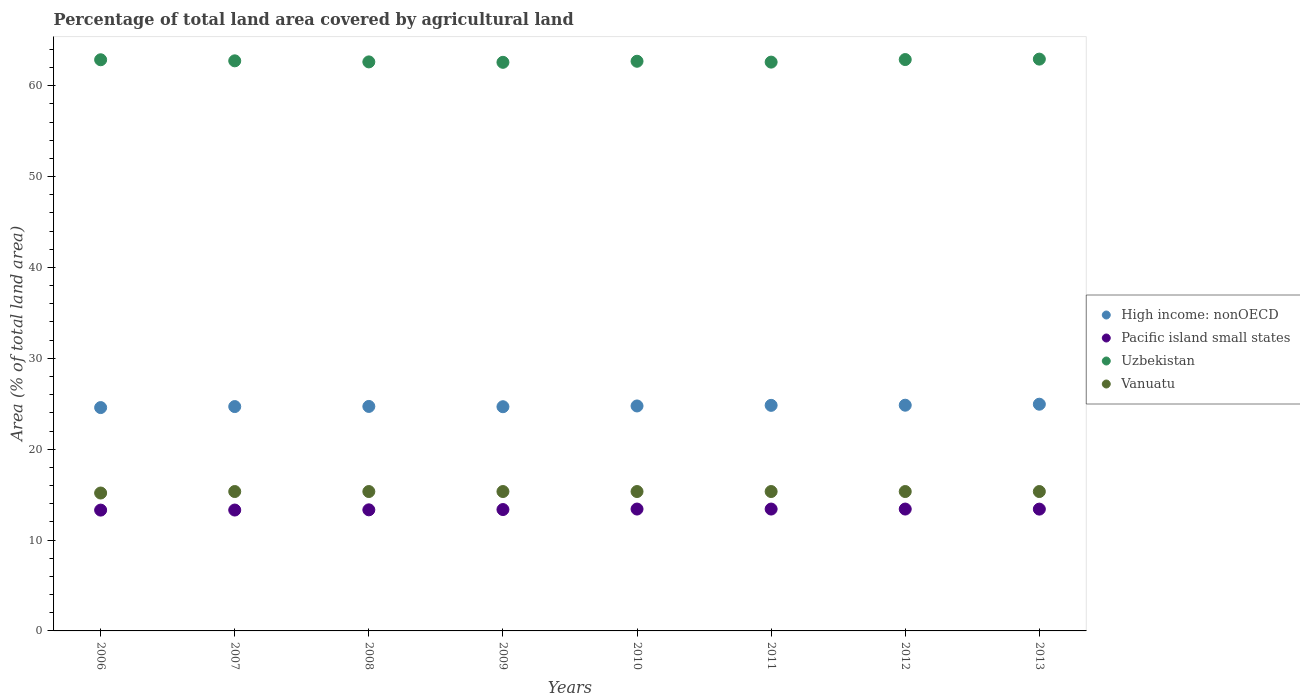How many different coloured dotlines are there?
Offer a terse response. 4. Is the number of dotlines equal to the number of legend labels?
Make the answer very short. Yes. What is the percentage of agricultural land in Vanuatu in 2013?
Offer a very short reply. 15.34. Across all years, what is the maximum percentage of agricultural land in Vanuatu?
Ensure brevity in your answer.  15.34. Across all years, what is the minimum percentage of agricultural land in Pacific island small states?
Your answer should be compact. 13.3. In which year was the percentage of agricultural land in Vanuatu maximum?
Provide a succinct answer. 2007. In which year was the percentage of agricultural land in High income: nonOECD minimum?
Offer a terse response. 2006. What is the total percentage of agricultural land in Pacific island small states in the graph?
Provide a succinct answer. 106.93. What is the difference between the percentage of agricultural land in Uzbekistan in 2006 and that in 2007?
Keep it short and to the point. 0.12. What is the difference between the percentage of agricultural land in Uzbekistan in 2010 and the percentage of agricultural land in High income: nonOECD in 2007?
Offer a terse response. 38. What is the average percentage of agricultural land in High income: nonOECD per year?
Your response must be concise. 24.75. In the year 2013, what is the difference between the percentage of agricultural land in Uzbekistan and percentage of agricultural land in High income: nonOECD?
Offer a terse response. 37.98. In how many years, is the percentage of agricultural land in Pacific island small states greater than 34 %?
Make the answer very short. 0. What is the ratio of the percentage of agricultural land in Pacific island small states in 2009 to that in 2010?
Provide a short and direct response. 1. What is the difference between the highest and the second highest percentage of agricultural land in Vanuatu?
Your response must be concise. 0. What is the difference between the highest and the lowest percentage of agricultural land in Vanuatu?
Your answer should be very brief. 0.16. Is the sum of the percentage of agricultural land in High income: nonOECD in 2007 and 2013 greater than the maximum percentage of agricultural land in Uzbekistan across all years?
Provide a short and direct response. No. Is it the case that in every year, the sum of the percentage of agricultural land in Uzbekistan and percentage of agricultural land in High income: nonOECD  is greater than the sum of percentage of agricultural land in Vanuatu and percentage of agricultural land in Pacific island small states?
Provide a succinct answer. Yes. Does the percentage of agricultural land in Vanuatu monotonically increase over the years?
Offer a terse response. No. Does the graph contain any zero values?
Your response must be concise. No. Does the graph contain grids?
Your answer should be very brief. No. How are the legend labels stacked?
Make the answer very short. Vertical. What is the title of the graph?
Make the answer very short. Percentage of total land area covered by agricultural land. Does "Malawi" appear as one of the legend labels in the graph?
Your response must be concise. No. What is the label or title of the X-axis?
Make the answer very short. Years. What is the label or title of the Y-axis?
Keep it short and to the point. Area (% of total land area). What is the Area (% of total land area) in High income: nonOECD in 2006?
Ensure brevity in your answer.  24.58. What is the Area (% of total land area) in Pacific island small states in 2006?
Offer a terse response. 13.3. What is the Area (% of total land area) in Uzbekistan in 2006?
Your response must be concise. 62.86. What is the Area (% of total land area) in Vanuatu in 2006?
Offer a terse response. 15.18. What is the Area (% of total land area) in High income: nonOECD in 2007?
Offer a terse response. 24.69. What is the Area (% of total land area) of Pacific island small states in 2007?
Offer a terse response. 13.3. What is the Area (% of total land area) of Uzbekistan in 2007?
Keep it short and to the point. 62.74. What is the Area (% of total land area) of Vanuatu in 2007?
Provide a short and direct response. 15.34. What is the Area (% of total land area) in High income: nonOECD in 2008?
Your response must be concise. 24.71. What is the Area (% of total land area) in Pacific island small states in 2008?
Provide a succinct answer. 13.33. What is the Area (% of total land area) in Uzbekistan in 2008?
Ensure brevity in your answer.  62.62. What is the Area (% of total land area) of Vanuatu in 2008?
Offer a terse response. 15.34. What is the Area (% of total land area) in High income: nonOECD in 2009?
Give a very brief answer. 24.67. What is the Area (% of total land area) of Pacific island small states in 2009?
Give a very brief answer. 13.36. What is the Area (% of total land area) of Uzbekistan in 2009?
Your response must be concise. 62.58. What is the Area (% of total land area) in Vanuatu in 2009?
Make the answer very short. 15.34. What is the Area (% of total land area) of High income: nonOECD in 2010?
Your response must be concise. 24.76. What is the Area (% of total land area) of Pacific island small states in 2010?
Make the answer very short. 13.41. What is the Area (% of total land area) of Uzbekistan in 2010?
Offer a terse response. 62.69. What is the Area (% of total land area) of Vanuatu in 2010?
Make the answer very short. 15.34. What is the Area (% of total land area) in High income: nonOECD in 2011?
Your answer should be compact. 24.83. What is the Area (% of total land area) of Pacific island small states in 2011?
Provide a succinct answer. 13.41. What is the Area (% of total land area) of Uzbekistan in 2011?
Provide a succinct answer. 62.6. What is the Area (% of total land area) of Vanuatu in 2011?
Offer a terse response. 15.34. What is the Area (% of total land area) in High income: nonOECD in 2012?
Make the answer very short. 24.84. What is the Area (% of total land area) in Pacific island small states in 2012?
Make the answer very short. 13.41. What is the Area (% of total land area) in Uzbekistan in 2012?
Keep it short and to the point. 62.88. What is the Area (% of total land area) in Vanuatu in 2012?
Your response must be concise. 15.34. What is the Area (% of total land area) of High income: nonOECD in 2013?
Provide a succinct answer. 24.95. What is the Area (% of total land area) of Pacific island small states in 2013?
Your answer should be compact. 13.4. What is the Area (% of total land area) of Uzbekistan in 2013?
Your answer should be very brief. 62.93. What is the Area (% of total land area) of Vanuatu in 2013?
Give a very brief answer. 15.34. Across all years, what is the maximum Area (% of total land area) in High income: nonOECD?
Provide a succinct answer. 24.95. Across all years, what is the maximum Area (% of total land area) in Pacific island small states?
Provide a short and direct response. 13.41. Across all years, what is the maximum Area (% of total land area) in Uzbekistan?
Make the answer very short. 62.93. Across all years, what is the maximum Area (% of total land area) in Vanuatu?
Your response must be concise. 15.34. Across all years, what is the minimum Area (% of total land area) in High income: nonOECD?
Provide a succinct answer. 24.58. Across all years, what is the minimum Area (% of total land area) of Pacific island small states?
Give a very brief answer. 13.3. Across all years, what is the minimum Area (% of total land area) in Uzbekistan?
Offer a terse response. 62.58. Across all years, what is the minimum Area (% of total land area) in Vanuatu?
Your answer should be compact. 15.18. What is the total Area (% of total land area) of High income: nonOECD in the graph?
Your answer should be very brief. 198.03. What is the total Area (% of total land area) of Pacific island small states in the graph?
Provide a short and direct response. 106.93. What is the total Area (% of total land area) of Uzbekistan in the graph?
Provide a succinct answer. 501.9. What is the total Area (% of total land area) of Vanuatu in the graph?
Ensure brevity in your answer.  122.56. What is the difference between the Area (% of total land area) in High income: nonOECD in 2006 and that in 2007?
Offer a very short reply. -0.11. What is the difference between the Area (% of total land area) of Pacific island small states in 2006 and that in 2007?
Give a very brief answer. -0.01. What is the difference between the Area (% of total land area) of Uzbekistan in 2006 and that in 2007?
Offer a terse response. 0.12. What is the difference between the Area (% of total land area) of Vanuatu in 2006 and that in 2007?
Your answer should be very brief. -0.16. What is the difference between the Area (% of total land area) of High income: nonOECD in 2006 and that in 2008?
Offer a very short reply. -0.13. What is the difference between the Area (% of total land area) in Pacific island small states in 2006 and that in 2008?
Your response must be concise. -0.03. What is the difference between the Area (% of total land area) in Uzbekistan in 2006 and that in 2008?
Your response must be concise. 0.24. What is the difference between the Area (% of total land area) in Vanuatu in 2006 and that in 2008?
Your answer should be very brief. -0.16. What is the difference between the Area (% of total land area) in High income: nonOECD in 2006 and that in 2009?
Your answer should be very brief. -0.09. What is the difference between the Area (% of total land area) of Pacific island small states in 2006 and that in 2009?
Give a very brief answer. -0.06. What is the difference between the Area (% of total land area) of Uzbekistan in 2006 and that in 2009?
Provide a succinct answer. 0.28. What is the difference between the Area (% of total land area) of Vanuatu in 2006 and that in 2009?
Make the answer very short. -0.16. What is the difference between the Area (% of total land area) in High income: nonOECD in 2006 and that in 2010?
Provide a short and direct response. -0.18. What is the difference between the Area (% of total land area) of Pacific island small states in 2006 and that in 2010?
Provide a short and direct response. -0.12. What is the difference between the Area (% of total land area) in Uzbekistan in 2006 and that in 2010?
Offer a very short reply. 0.16. What is the difference between the Area (% of total land area) in Vanuatu in 2006 and that in 2010?
Offer a terse response. -0.16. What is the difference between the Area (% of total land area) in High income: nonOECD in 2006 and that in 2011?
Your answer should be very brief. -0.25. What is the difference between the Area (% of total land area) of Pacific island small states in 2006 and that in 2011?
Offer a terse response. -0.12. What is the difference between the Area (% of total land area) of Uzbekistan in 2006 and that in 2011?
Your response must be concise. 0.26. What is the difference between the Area (% of total land area) in Vanuatu in 2006 and that in 2011?
Give a very brief answer. -0.16. What is the difference between the Area (% of total land area) of High income: nonOECD in 2006 and that in 2012?
Your answer should be very brief. -0.26. What is the difference between the Area (% of total land area) in Pacific island small states in 2006 and that in 2012?
Provide a succinct answer. -0.12. What is the difference between the Area (% of total land area) of Uzbekistan in 2006 and that in 2012?
Ensure brevity in your answer.  -0.02. What is the difference between the Area (% of total land area) of Vanuatu in 2006 and that in 2012?
Provide a short and direct response. -0.16. What is the difference between the Area (% of total land area) of High income: nonOECD in 2006 and that in 2013?
Ensure brevity in your answer.  -0.37. What is the difference between the Area (% of total land area) in Pacific island small states in 2006 and that in 2013?
Keep it short and to the point. -0.11. What is the difference between the Area (% of total land area) in Uzbekistan in 2006 and that in 2013?
Your response must be concise. -0.07. What is the difference between the Area (% of total land area) of Vanuatu in 2006 and that in 2013?
Offer a terse response. -0.16. What is the difference between the Area (% of total land area) in High income: nonOECD in 2007 and that in 2008?
Ensure brevity in your answer.  -0.02. What is the difference between the Area (% of total land area) of Pacific island small states in 2007 and that in 2008?
Provide a succinct answer. -0.02. What is the difference between the Area (% of total land area) in Uzbekistan in 2007 and that in 2008?
Keep it short and to the point. 0.12. What is the difference between the Area (% of total land area) in High income: nonOECD in 2007 and that in 2009?
Ensure brevity in your answer.  0.02. What is the difference between the Area (% of total land area) of Pacific island small states in 2007 and that in 2009?
Offer a very short reply. -0.05. What is the difference between the Area (% of total land area) of Uzbekistan in 2007 and that in 2009?
Ensure brevity in your answer.  0.16. What is the difference between the Area (% of total land area) in Vanuatu in 2007 and that in 2009?
Give a very brief answer. 0. What is the difference between the Area (% of total land area) of High income: nonOECD in 2007 and that in 2010?
Offer a very short reply. -0.07. What is the difference between the Area (% of total land area) of Pacific island small states in 2007 and that in 2010?
Offer a terse response. -0.11. What is the difference between the Area (% of total land area) in Uzbekistan in 2007 and that in 2010?
Offer a terse response. 0.05. What is the difference between the Area (% of total land area) of Vanuatu in 2007 and that in 2010?
Your response must be concise. 0. What is the difference between the Area (% of total land area) of High income: nonOECD in 2007 and that in 2011?
Give a very brief answer. -0.13. What is the difference between the Area (% of total land area) in Pacific island small states in 2007 and that in 2011?
Offer a very short reply. -0.11. What is the difference between the Area (% of total land area) of Uzbekistan in 2007 and that in 2011?
Keep it short and to the point. 0.14. What is the difference between the Area (% of total land area) in High income: nonOECD in 2007 and that in 2012?
Provide a short and direct response. -0.15. What is the difference between the Area (% of total land area) of Pacific island small states in 2007 and that in 2012?
Give a very brief answer. -0.11. What is the difference between the Area (% of total land area) in Uzbekistan in 2007 and that in 2012?
Offer a very short reply. -0.14. What is the difference between the Area (% of total land area) in Vanuatu in 2007 and that in 2012?
Give a very brief answer. 0. What is the difference between the Area (% of total land area) of High income: nonOECD in 2007 and that in 2013?
Make the answer very short. -0.26. What is the difference between the Area (% of total land area) in Pacific island small states in 2007 and that in 2013?
Provide a succinct answer. -0.1. What is the difference between the Area (% of total land area) in Uzbekistan in 2007 and that in 2013?
Offer a very short reply. -0.19. What is the difference between the Area (% of total land area) of High income: nonOECD in 2008 and that in 2009?
Your answer should be very brief. 0.03. What is the difference between the Area (% of total land area) of Pacific island small states in 2008 and that in 2009?
Keep it short and to the point. -0.03. What is the difference between the Area (% of total land area) of Uzbekistan in 2008 and that in 2009?
Offer a very short reply. 0.05. What is the difference between the Area (% of total land area) in High income: nonOECD in 2008 and that in 2010?
Your answer should be compact. -0.05. What is the difference between the Area (% of total land area) of Pacific island small states in 2008 and that in 2010?
Make the answer very short. -0.09. What is the difference between the Area (% of total land area) of Uzbekistan in 2008 and that in 2010?
Make the answer very short. -0.07. What is the difference between the Area (% of total land area) in Vanuatu in 2008 and that in 2010?
Give a very brief answer. 0. What is the difference between the Area (% of total land area) of High income: nonOECD in 2008 and that in 2011?
Provide a short and direct response. -0.12. What is the difference between the Area (% of total land area) in Pacific island small states in 2008 and that in 2011?
Make the answer very short. -0.09. What is the difference between the Area (% of total land area) of Uzbekistan in 2008 and that in 2011?
Ensure brevity in your answer.  0.02. What is the difference between the Area (% of total land area) of High income: nonOECD in 2008 and that in 2012?
Make the answer very short. -0.14. What is the difference between the Area (% of total land area) of Pacific island small states in 2008 and that in 2012?
Your response must be concise. -0.09. What is the difference between the Area (% of total land area) in Uzbekistan in 2008 and that in 2012?
Make the answer very short. -0.26. What is the difference between the Area (% of total land area) of Vanuatu in 2008 and that in 2012?
Offer a terse response. 0. What is the difference between the Area (% of total land area) in High income: nonOECD in 2008 and that in 2013?
Offer a terse response. -0.24. What is the difference between the Area (% of total land area) of Pacific island small states in 2008 and that in 2013?
Your answer should be compact. -0.08. What is the difference between the Area (% of total land area) in Uzbekistan in 2008 and that in 2013?
Offer a terse response. -0.31. What is the difference between the Area (% of total land area) of Vanuatu in 2008 and that in 2013?
Your answer should be very brief. 0. What is the difference between the Area (% of total land area) in High income: nonOECD in 2009 and that in 2010?
Your response must be concise. -0.08. What is the difference between the Area (% of total land area) of Pacific island small states in 2009 and that in 2010?
Your response must be concise. -0.05. What is the difference between the Area (% of total land area) of Uzbekistan in 2009 and that in 2010?
Keep it short and to the point. -0.12. What is the difference between the Area (% of total land area) in Vanuatu in 2009 and that in 2010?
Provide a short and direct response. 0. What is the difference between the Area (% of total land area) in High income: nonOECD in 2009 and that in 2011?
Ensure brevity in your answer.  -0.15. What is the difference between the Area (% of total land area) in Pacific island small states in 2009 and that in 2011?
Provide a succinct answer. -0.05. What is the difference between the Area (% of total land area) in Uzbekistan in 2009 and that in 2011?
Your response must be concise. -0.02. What is the difference between the Area (% of total land area) in Pacific island small states in 2009 and that in 2012?
Ensure brevity in your answer.  -0.05. What is the difference between the Area (% of total land area) of Uzbekistan in 2009 and that in 2012?
Provide a succinct answer. -0.31. What is the difference between the Area (% of total land area) in High income: nonOECD in 2009 and that in 2013?
Keep it short and to the point. -0.28. What is the difference between the Area (% of total land area) of Pacific island small states in 2009 and that in 2013?
Your response must be concise. -0.05. What is the difference between the Area (% of total land area) of Uzbekistan in 2009 and that in 2013?
Your response must be concise. -0.35. What is the difference between the Area (% of total land area) of High income: nonOECD in 2010 and that in 2011?
Your answer should be compact. -0.07. What is the difference between the Area (% of total land area) in Pacific island small states in 2010 and that in 2011?
Your answer should be compact. 0. What is the difference between the Area (% of total land area) of Uzbekistan in 2010 and that in 2011?
Your answer should be compact. 0.09. What is the difference between the Area (% of total land area) of Vanuatu in 2010 and that in 2011?
Offer a very short reply. 0. What is the difference between the Area (% of total land area) in High income: nonOECD in 2010 and that in 2012?
Provide a succinct answer. -0.08. What is the difference between the Area (% of total land area) in Pacific island small states in 2010 and that in 2012?
Your response must be concise. 0. What is the difference between the Area (% of total land area) of Uzbekistan in 2010 and that in 2012?
Ensure brevity in your answer.  -0.19. What is the difference between the Area (% of total land area) of High income: nonOECD in 2010 and that in 2013?
Offer a terse response. -0.19. What is the difference between the Area (% of total land area) in Pacific island small states in 2010 and that in 2013?
Make the answer very short. 0.01. What is the difference between the Area (% of total land area) in Uzbekistan in 2010 and that in 2013?
Give a very brief answer. -0.24. What is the difference between the Area (% of total land area) of Vanuatu in 2010 and that in 2013?
Offer a terse response. 0. What is the difference between the Area (% of total land area) of High income: nonOECD in 2011 and that in 2012?
Give a very brief answer. -0.02. What is the difference between the Area (% of total land area) in Uzbekistan in 2011 and that in 2012?
Your answer should be very brief. -0.28. What is the difference between the Area (% of total land area) in High income: nonOECD in 2011 and that in 2013?
Provide a short and direct response. -0.12. What is the difference between the Area (% of total land area) of Pacific island small states in 2011 and that in 2013?
Provide a short and direct response. 0.01. What is the difference between the Area (% of total land area) of Uzbekistan in 2011 and that in 2013?
Ensure brevity in your answer.  -0.33. What is the difference between the Area (% of total land area) in Vanuatu in 2011 and that in 2013?
Provide a short and direct response. 0. What is the difference between the Area (% of total land area) in High income: nonOECD in 2012 and that in 2013?
Offer a very short reply. -0.11. What is the difference between the Area (% of total land area) of Pacific island small states in 2012 and that in 2013?
Your answer should be compact. 0.01. What is the difference between the Area (% of total land area) in Uzbekistan in 2012 and that in 2013?
Your response must be concise. -0.05. What is the difference between the Area (% of total land area) in High income: nonOECD in 2006 and the Area (% of total land area) in Pacific island small states in 2007?
Provide a short and direct response. 11.28. What is the difference between the Area (% of total land area) of High income: nonOECD in 2006 and the Area (% of total land area) of Uzbekistan in 2007?
Provide a short and direct response. -38.16. What is the difference between the Area (% of total land area) in High income: nonOECD in 2006 and the Area (% of total land area) in Vanuatu in 2007?
Provide a short and direct response. 9.24. What is the difference between the Area (% of total land area) of Pacific island small states in 2006 and the Area (% of total land area) of Uzbekistan in 2007?
Your answer should be very brief. -49.44. What is the difference between the Area (% of total land area) of Pacific island small states in 2006 and the Area (% of total land area) of Vanuatu in 2007?
Provide a short and direct response. -2.04. What is the difference between the Area (% of total land area) of Uzbekistan in 2006 and the Area (% of total land area) of Vanuatu in 2007?
Your answer should be compact. 47.52. What is the difference between the Area (% of total land area) in High income: nonOECD in 2006 and the Area (% of total land area) in Pacific island small states in 2008?
Provide a succinct answer. 11.25. What is the difference between the Area (% of total land area) of High income: nonOECD in 2006 and the Area (% of total land area) of Uzbekistan in 2008?
Your answer should be compact. -38.04. What is the difference between the Area (% of total land area) of High income: nonOECD in 2006 and the Area (% of total land area) of Vanuatu in 2008?
Offer a very short reply. 9.24. What is the difference between the Area (% of total land area) in Pacific island small states in 2006 and the Area (% of total land area) in Uzbekistan in 2008?
Offer a terse response. -49.33. What is the difference between the Area (% of total land area) in Pacific island small states in 2006 and the Area (% of total land area) in Vanuatu in 2008?
Your answer should be very brief. -2.04. What is the difference between the Area (% of total land area) in Uzbekistan in 2006 and the Area (% of total land area) in Vanuatu in 2008?
Provide a succinct answer. 47.52. What is the difference between the Area (% of total land area) in High income: nonOECD in 2006 and the Area (% of total land area) in Pacific island small states in 2009?
Your answer should be compact. 11.22. What is the difference between the Area (% of total land area) of High income: nonOECD in 2006 and the Area (% of total land area) of Uzbekistan in 2009?
Your answer should be compact. -38. What is the difference between the Area (% of total land area) of High income: nonOECD in 2006 and the Area (% of total land area) of Vanuatu in 2009?
Provide a short and direct response. 9.24. What is the difference between the Area (% of total land area) in Pacific island small states in 2006 and the Area (% of total land area) in Uzbekistan in 2009?
Provide a short and direct response. -49.28. What is the difference between the Area (% of total land area) of Pacific island small states in 2006 and the Area (% of total land area) of Vanuatu in 2009?
Provide a succinct answer. -2.04. What is the difference between the Area (% of total land area) in Uzbekistan in 2006 and the Area (% of total land area) in Vanuatu in 2009?
Offer a very short reply. 47.52. What is the difference between the Area (% of total land area) of High income: nonOECD in 2006 and the Area (% of total land area) of Pacific island small states in 2010?
Keep it short and to the point. 11.17. What is the difference between the Area (% of total land area) in High income: nonOECD in 2006 and the Area (% of total land area) in Uzbekistan in 2010?
Make the answer very short. -38.11. What is the difference between the Area (% of total land area) in High income: nonOECD in 2006 and the Area (% of total land area) in Vanuatu in 2010?
Provide a succinct answer. 9.24. What is the difference between the Area (% of total land area) of Pacific island small states in 2006 and the Area (% of total land area) of Uzbekistan in 2010?
Your response must be concise. -49.4. What is the difference between the Area (% of total land area) of Pacific island small states in 2006 and the Area (% of total land area) of Vanuatu in 2010?
Offer a terse response. -2.04. What is the difference between the Area (% of total land area) in Uzbekistan in 2006 and the Area (% of total land area) in Vanuatu in 2010?
Ensure brevity in your answer.  47.52. What is the difference between the Area (% of total land area) in High income: nonOECD in 2006 and the Area (% of total land area) in Pacific island small states in 2011?
Your answer should be very brief. 11.17. What is the difference between the Area (% of total land area) of High income: nonOECD in 2006 and the Area (% of total land area) of Uzbekistan in 2011?
Give a very brief answer. -38.02. What is the difference between the Area (% of total land area) of High income: nonOECD in 2006 and the Area (% of total land area) of Vanuatu in 2011?
Keep it short and to the point. 9.24. What is the difference between the Area (% of total land area) of Pacific island small states in 2006 and the Area (% of total land area) of Uzbekistan in 2011?
Provide a succinct answer. -49.3. What is the difference between the Area (% of total land area) in Pacific island small states in 2006 and the Area (% of total land area) in Vanuatu in 2011?
Your answer should be compact. -2.04. What is the difference between the Area (% of total land area) in Uzbekistan in 2006 and the Area (% of total land area) in Vanuatu in 2011?
Provide a short and direct response. 47.52. What is the difference between the Area (% of total land area) of High income: nonOECD in 2006 and the Area (% of total land area) of Pacific island small states in 2012?
Offer a very short reply. 11.17. What is the difference between the Area (% of total land area) of High income: nonOECD in 2006 and the Area (% of total land area) of Uzbekistan in 2012?
Ensure brevity in your answer.  -38.3. What is the difference between the Area (% of total land area) in High income: nonOECD in 2006 and the Area (% of total land area) in Vanuatu in 2012?
Ensure brevity in your answer.  9.24. What is the difference between the Area (% of total land area) in Pacific island small states in 2006 and the Area (% of total land area) in Uzbekistan in 2012?
Keep it short and to the point. -49.59. What is the difference between the Area (% of total land area) in Pacific island small states in 2006 and the Area (% of total land area) in Vanuatu in 2012?
Your answer should be compact. -2.04. What is the difference between the Area (% of total land area) in Uzbekistan in 2006 and the Area (% of total land area) in Vanuatu in 2012?
Ensure brevity in your answer.  47.52. What is the difference between the Area (% of total land area) of High income: nonOECD in 2006 and the Area (% of total land area) of Pacific island small states in 2013?
Ensure brevity in your answer.  11.18. What is the difference between the Area (% of total land area) in High income: nonOECD in 2006 and the Area (% of total land area) in Uzbekistan in 2013?
Your answer should be compact. -38.35. What is the difference between the Area (% of total land area) in High income: nonOECD in 2006 and the Area (% of total land area) in Vanuatu in 2013?
Your answer should be very brief. 9.24. What is the difference between the Area (% of total land area) in Pacific island small states in 2006 and the Area (% of total land area) in Uzbekistan in 2013?
Keep it short and to the point. -49.63. What is the difference between the Area (% of total land area) in Pacific island small states in 2006 and the Area (% of total land area) in Vanuatu in 2013?
Ensure brevity in your answer.  -2.04. What is the difference between the Area (% of total land area) in Uzbekistan in 2006 and the Area (% of total land area) in Vanuatu in 2013?
Your answer should be compact. 47.52. What is the difference between the Area (% of total land area) in High income: nonOECD in 2007 and the Area (% of total land area) in Pacific island small states in 2008?
Ensure brevity in your answer.  11.36. What is the difference between the Area (% of total land area) of High income: nonOECD in 2007 and the Area (% of total land area) of Uzbekistan in 2008?
Offer a terse response. -37.93. What is the difference between the Area (% of total land area) in High income: nonOECD in 2007 and the Area (% of total land area) in Vanuatu in 2008?
Your answer should be compact. 9.35. What is the difference between the Area (% of total land area) of Pacific island small states in 2007 and the Area (% of total land area) of Uzbekistan in 2008?
Make the answer very short. -49.32. What is the difference between the Area (% of total land area) in Pacific island small states in 2007 and the Area (% of total land area) in Vanuatu in 2008?
Offer a very short reply. -2.04. What is the difference between the Area (% of total land area) in Uzbekistan in 2007 and the Area (% of total land area) in Vanuatu in 2008?
Your answer should be compact. 47.4. What is the difference between the Area (% of total land area) of High income: nonOECD in 2007 and the Area (% of total land area) of Pacific island small states in 2009?
Provide a short and direct response. 11.33. What is the difference between the Area (% of total land area) of High income: nonOECD in 2007 and the Area (% of total land area) of Uzbekistan in 2009?
Your answer should be compact. -37.89. What is the difference between the Area (% of total land area) in High income: nonOECD in 2007 and the Area (% of total land area) in Vanuatu in 2009?
Your answer should be compact. 9.35. What is the difference between the Area (% of total land area) in Pacific island small states in 2007 and the Area (% of total land area) in Uzbekistan in 2009?
Give a very brief answer. -49.27. What is the difference between the Area (% of total land area) in Pacific island small states in 2007 and the Area (% of total land area) in Vanuatu in 2009?
Ensure brevity in your answer.  -2.04. What is the difference between the Area (% of total land area) of Uzbekistan in 2007 and the Area (% of total land area) of Vanuatu in 2009?
Provide a short and direct response. 47.4. What is the difference between the Area (% of total land area) in High income: nonOECD in 2007 and the Area (% of total land area) in Pacific island small states in 2010?
Make the answer very short. 11.28. What is the difference between the Area (% of total land area) in High income: nonOECD in 2007 and the Area (% of total land area) in Uzbekistan in 2010?
Offer a very short reply. -38. What is the difference between the Area (% of total land area) of High income: nonOECD in 2007 and the Area (% of total land area) of Vanuatu in 2010?
Provide a succinct answer. 9.35. What is the difference between the Area (% of total land area) of Pacific island small states in 2007 and the Area (% of total land area) of Uzbekistan in 2010?
Provide a short and direct response. -49.39. What is the difference between the Area (% of total land area) of Pacific island small states in 2007 and the Area (% of total land area) of Vanuatu in 2010?
Keep it short and to the point. -2.04. What is the difference between the Area (% of total land area) of Uzbekistan in 2007 and the Area (% of total land area) of Vanuatu in 2010?
Your response must be concise. 47.4. What is the difference between the Area (% of total land area) in High income: nonOECD in 2007 and the Area (% of total land area) in Pacific island small states in 2011?
Provide a short and direct response. 11.28. What is the difference between the Area (% of total land area) of High income: nonOECD in 2007 and the Area (% of total land area) of Uzbekistan in 2011?
Offer a very short reply. -37.91. What is the difference between the Area (% of total land area) of High income: nonOECD in 2007 and the Area (% of total land area) of Vanuatu in 2011?
Give a very brief answer. 9.35. What is the difference between the Area (% of total land area) in Pacific island small states in 2007 and the Area (% of total land area) in Uzbekistan in 2011?
Keep it short and to the point. -49.3. What is the difference between the Area (% of total land area) in Pacific island small states in 2007 and the Area (% of total land area) in Vanuatu in 2011?
Make the answer very short. -2.04. What is the difference between the Area (% of total land area) in Uzbekistan in 2007 and the Area (% of total land area) in Vanuatu in 2011?
Offer a very short reply. 47.4. What is the difference between the Area (% of total land area) of High income: nonOECD in 2007 and the Area (% of total land area) of Pacific island small states in 2012?
Offer a very short reply. 11.28. What is the difference between the Area (% of total land area) in High income: nonOECD in 2007 and the Area (% of total land area) in Uzbekistan in 2012?
Keep it short and to the point. -38.19. What is the difference between the Area (% of total land area) in High income: nonOECD in 2007 and the Area (% of total land area) in Vanuatu in 2012?
Offer a very short reply. 9.35. What is the difference between the Area (% of total land area) in Pacific island small states in 2007 and the Area (% of total land area) in Uzbekistan in 2012?
Ensure brevity in your answer.  -49.58. What is the difference between the Area (% of total land area) in Pacific island small states in 2007 and the Area (% of total land area) in Vanuatu in 2012?
Provide a short and direct response. -2.04. What is the difference between the Area (% of total land area) in Uzbekistan in 2007 and the Area (% of total land area) in Vanuatu in 2012?
Your response must be concise. 47.4. What is the difference between the Area (% of total land area) in High income: nonOECD in 2007 and the Area (% of total land area) in Pacific island small states in 2013?
Keep it short and to the point. 11.29. What is the difference between the Area (% of total land area) of High income: nonOECD in 2007 and the Area (% of total land area) of Uzbekistan in 2013?
Offer a very short reply. -38.24. What is the difference between the Area (% of total land area) of High income: nonOECD in 2007 and the Area (% of total land area) of Vanuatu in 2013?
Your response must be concise. 9.35. What is the difference between the Area (% of total land area) of Pacific island small states in 2007 and the Area (% of total land area) of Uzbekistan in 2013?
Your answer should be compact. -49.63. What is the difference between the Area (% of total land area) in Pacific island small states in 2007 and the Area (% of total land area) in Vanuatu in 2013?
Make the answer very short. -2.04. What is the difference between the Area (% of total land area) in Uzbekistan in 2007 and the Area (% of total land area) in Vanuatu in 2013?
Keep it short and to the point. 47.4. What is the difference between the Area (% of total land area) in High income: nonOECD in 2008 and the Area (% of total land area) in Pacific island small states in 2009?
Provide a short and direct response. 11.35. What is the difference between the Area (% of total land area) of High income: nonOECD in 2008 and the Area (% of total land area) of Uzbekistan in 2009?
Keep it short and to the point. -37.87. What is the difference between the Area (% of total land area) of High income: nonOECD in 2008 and the Area (% of total land area) of Vanuatu in 2009?
Provide a succinct answer. 9.37. What is the difference between the Area (% of total land area) in Pacific island small states in 2008 and the Area (% of total land area) in Uzbekistan in 2009?
Your response must be concise. -49.25. What is the difference between the Area (% of total land area) of Pacific island small states in 2008 and the Area (% of total land area) of Vanuatu in 2009?
Make the answer very short. -2.01. What is the difference between the Area (% of total land area) of Uzbekistan in 2008 and the Area (% of total land area) of Vanuatu in 2009?
Keep it short and to the point. 47.28. What is the difference between the Area (% of total land area) of High income: nonOECD in 2008 and the Area (% of total land area) of Pacific island small states in 2010?
Your answer should be very brief. 11.29. What is the difference between the Area (% of total land area) of High income: nonOECD in 2008 and the Area (% of total land area) of Uzbekistan in 2010?
Keep it short and to the point. -37.99. What is the difference between the Area (% of total land area) in High income: nonOECD in 2008 and the Area (% of total land area) in Vanuatu in 2010?
Make the answer very short. 9.37. What is the difference between the Area (% of total land area) in Pacific island small states in 2008 and the Area (% of total land area) in Uzbekistan in 2010?
Offer a very short reply. -49.37. What is the difference between the Area (% of total land area) in Pacific island small states in 2008 and the Area (% of total land area) in Vanuatu in 2010?
Make the answer very short. -2.01. What is the difference between the Area (% of total land area) in Uzbekistan in 2008 and the Area (% of total land area) in Vanuatu in 2010?
Keep it short and to the point. 47.28. What is the difference between the Area (% of total land area) of High income: nonOECD in 2008 and the Area (% of total land area) of Pacific island small states in 2011?
Provide a succinct answer. 11.29. What is the difference between the Area (% of total land area) in High income: nonOECD in 2008 and the Area (% of total land area) in Uzbekistan in 2011?
Ensure brevity in your answer.  -37.89. What is the difference between the Area (% of total land area) in High income: nonOECD in 2008 and the Area (% of total land area) in Vanuatu in 2011?
Give a very brief answer. 9.37. What is the difference between the Area (% of total land area) of Pacific island small states in 2008 and the Area (% of total land area) of Uzbekistan in 2011?
Your answer should be very brief. -49.27. What is the difference between the Area (% of total land area) of Pacific island small states in 2008 and the Area (% of total land area) of Vanuatu in 2011?
Give a very brief answer. -2.01. What is the difference between the Area (% of total land area) in Uzbekistan in 2008 and the Area (% of total land area) in Vanuatu in 2011?
Give a very brief answer. 47.28. What is the difference between the Area (% of total land area) of High income: nonOECD in 2008 and the Area (% of total land area) of Pacific island small states in 2012?
Make the answer very short. 11.29. What is the difference between the Area (% of total land area) in High income: nonOECD in 2008 and the Area (% of total land area) in Uzbekistan in 2012?
Provide a succinct answer. -38.18. What is the difference between the Area (% of total land area) of High income: nonOECD in 2008 and the Area (% of total land area) of Vanuatu in 2012?
Provide a short and direct response. 9.37. What is the difference between the Area (% of total land area) in Pacific island small states in 2008 and the Area (% of total land area) in Uzbekistan in 2012?
Offer a very short reply. -49.56. What is the difference between the Area (% of total land area) of Pacific island small states in 2008 and the Area (% of total land area) of Vanuatu in 2012?
Keep it short and to the point. -2.01. What is the difference between the Area (% of total land area) of Uzbekistan in 2008 and the Area (% of total land area) of Vanuatu in 2012?
Offer a very short reply. 47.28. What is the difference between the Area (% of total land area) in High income: nonOECD in 2008 and the Area (% of total land area) in Pacific island small states in 2013?
Offer a terse response. 11.3. What is the difference between the Area (% of total land area) of High income: nonOECD in 2008 and the Area (% of total land area) of Uzbekistan in 2013?
Give a very brief answer. -38.22. What is the difference between the Area (% of total land area) of High income: nonOECD in 2008 and the Area (% of total land area) of Vanuatu in 2013?
Your response must be concise. 9.37. What is the difference between the Area (% of total land area) in Pacific island small states in 2008 and the Area (% of total land area) in Uzbekistan in 2013?
Your response must be concise. -49.6. What is the difference between the Area (% of total land area) in Pacific island small states in 2008 and the Area (% of total land area) in Vanuatu in 2013?
Give a very brief answer. -2.01. What is the difference between the Area (% of total land area) in Uzbekistan in 2008 and the Area (% of total land area) in Vanuatu in 2013?
Keep it short and to the point. 47.28. What is the difference between the Area (% of total land area) in High income: nonOECD in 2009 and the Area (% of total land area) in Pacific island small states in 2010?
Offer a very short reply. 11.26. What is the difference between the Area (% of total land area) in High income: nonOECD in 2009 and the Area (% of total land area) in Uzbekistan in 2010?
Your answer should be compact. -38.02. What is the difference between the Area (% of total land area) in High income: nonOECD in 2009 and the Area (% of total land area) in Vanuatu in 2010?
Offer a terse response. 9.33. What is the difference between the Area (% of total land area) of Pacific island small states in 2009 and the Area (% of total land area) of Uzbekistan in 2010?
Give a very brief answer. -49.34. What is the difference between the Area (% of total land area) of Pacific island small states in 2009 and the Area (% of total land area) of Vanuatu in 2010?
Offer a very short reply. -1.98. What is the difference between the Area (% of total land area) of Uzbekistan in 2009 and the Area (% of total land area) of Vanuatu in 2010?
Make the answer very short. 47.24. What is the difference between the Area (% of total land area) of High income: nonOECD in 2009 and the Area (% of total land area) of Pacific island small states in 2011?
Your answer should be compact. 11.26. What is the difference between the Area (% of total land area) in High income: nonOECD in 2009 and the Area (% of total land area) in Uzbekistan in 2011?
Your answer should be compact. -37.93. What is the difference between the Area (% of total land area) of High income: nonOECD in 2009 and the Area (% of total land area) of Vanuatu in 2011?
Ensure brevity in your answer.  9.33. What is the difference between the Area (% of total land area) in Pacific island small states in 2009 and the Area (% of total land area) in Uzbekistan in 2011?
Make the answer very short. -49.24. What is the difference between the Area (% of total land area) in Pacific island small states in 2009 and the Area (% of total land area) in Vanuatu in 2011?
Offer a terse response. -1.98. What is the difference between the Area (% of total land area) of Uzbekistan in 2009 and the Area (% of total land area) of Vanuatu in 2011?
Offer a terse response. 47.24. What is the difference between the Area (% of total land area) in High income: nonOECD in 2009 and the Area (% of total land area) in Pacific island small states in 2012?
Make the answer very short. 11.26. What is the difference between the Area (% of total land area) of High income: nonOECD in 2009 and the Area (% of total land area) of Uzbekistan in 2012?
Make the answer very short. -38.21. What is the difference between the Area (% of total land area) in High income: nonOECD in 2009 and the Area (% of total land area) in Vanuatu in 2012?
Ensure brevity in your answer.  9.33. What is the difference between the Area (% of total land area) of Pacific island small states in 2009 and the Area (% of total land area) of Uzbekistan in 2012?
Provide a short and direct response. -49.52. What is the difference between the Area (% of total land area) of Pacific island small states in 2009 and the Area (% of total land area) of Vanuatu in 2012?
Keep it short and to the point. -1.98. What is the difference between the Area (% of total land area) in Uzbekistan in 2009 and the Area (% of total land area) in Vanuatu in 2012?
Offer a terse response. 47.24. What is the difference between the Area (% of total land area) of High income: nonOECD in 2009 and the Area (% of total land area) of Pacific island small states in 2013?
Give a very brief answer. 11.27. What is the difference between the Area (% of total land area) in High income: nonOECD in 2009 and the Area (% of total land area) in Uzbekistan in 2013?
Offer a terse response. -38.25. What is the difference between the Area (% of total land area) in High income: nonOECD in 2009 and the Area (% of total land area) in Vanuatu in 2013?
Make the answer very short. 9.33. What is the difference between the Area (% of total land area) of Pacific island small states in 2009 and the Area (% of total land area) of Uzbekistan in 2013?
Make the answer very short. -49.57. What is the difference between the Area (% of total land area) of Pacific island small states in 2009 and the Area (% of total land area) of Vanuatu in 2013?
Keep it short and to the point. -1.98. What is the difference between the Area (% of total land area) of Uzbekistan in 2009 and the Area (% of total land area) of Vanuatu in 2013?
Offer a very short reply. 47.24. What is the difference between the Area (% of total land area) in High income: nonOECD in 2010 and the Area (% of total land area) in Pacific island small states in 2011?
Provide a short and direct response. 11.35. What is the difference between the Area (% of total land area) in High income: nonOECD in 2010 and the Area (% of total land area) in Uzbekistan in 2011?
Your answer should be very brief. -37.84. What is the difference between the Area (% of total land area) in High income: nonOECD in 2010 and the Area (% of total land area) in Vanuatu in 2011?
Keep it short and to the point. 9.42. What is the difference between the Area (% of total land area) in Pacific island small states in 2010 and the Area (% of total land area) in Uzbekistan in 2011?
Offer a terse response. -49.19. What is the difference between the Area (% of total land area) in Pacific island small states in 2010 and the Area (% of total land area) in Vanuatu in 2011?
Offer a very short reply. -1.93. What is the difference between the Area (% of total land area) in Uzbekistan in 2010 and the Area (% of total land area) in Vanuatu in 2011?
Provide a succinct answer. 47.35. What is the difference between the Area (% of total land area) in High income: nonOECD in 2010 and the Area (% of total land area) in Pacific island small states in 2012?
Provide a short and direct response. 11.35. What is the difference between the Area (% of total land area) of High income: nonOECD in 2010 and the Area (% of total land area) of Uzbekistan in 2012?
Your answer should be very brief. -38.12. What is the difference between the Area (% of total land area) of High income: nonOECD in 2010 and the Area (% of total land area) of Vanuatu in 2012?
Keep it short and to the point. 9.42. What is the difference between the Area (% of total land area) in Pacific island small states in 2010 and the Area (% of total land area) in Uzbekistan in 2012?
Your answer should be very brief. -49.47. What is the difference between the Area (% of total land area) in Pacific island small states in 2010 and the Area (% of total land area) in Vanuatu in 2012?
Your answer should be very brief. -1.93. What is the difference between the Area (% of total land area) of Uzbekistan in 2010 and the Area (% of total land area) of Vanuatu in 2012?
Give a very brief answer. 47.35. What is the difference between the Area (% of total land area) in High income: nonOECD in 2010 and the Area (% of total land area) in Pacific island small states in 2013?
Your answer should be very brief. 11.35. What is the difference between the Area (% of total land area) of High income: nonOECD in 2010 and the Area (% of total land area) of Uzbekistan in 2013?
Your answer should be compact. -38.17. What is the difference between the Area (% of total land area) in High income: nonOECD in 2010 and the Area (% of total land area) in Vanuatu in 2013?
Provide a short and direct response. 9.42. What is the difference between the Area (% of total land area) of Pacific island small states in 2010 and the Area (% of total land area) of Uzbekistan in 2013?
Your response must be concise. -49.52. What is the difference between the Area (% of total land area) of Pacific island small states in 2010 and the Area (% of total land area) of Vanuatu in 2013?
Your answer should be very brief. -1.93. What is the difference between the Area (% of total land area) in Uzbekistan in 2010 and the Area (% of total land area) in Vanuatu in 2013?
Offer a terse response. 47.35. What is the difference between the Area (% of total land area) of High income: nonOECD in 2011 and the Area (% of total land area) of Pacific island small states in 2012?
Your answer should be compact. 11.41. What is the difference between the Area (% of total land area) in High income: nonOECD in 2011 and the Area (% of total land area) in Uzbekistan in 2012?
Give a very brief answer. -38.06. What is the difference between the Area (% of total land area) in High income: nonOECD in 2011 and the Area (% of total land area) in Vanuatu in 2012?
Provide a short and direct response. 9.48. What is the difference between the Area (% of total land area) in Pacific island small states in 2011 and the Area (% of total land area) in Uzbekistan in 2012?
Provide a succinct answer. -49.47. What is the difference between the Area (% of total land area) in Pacific island small states in 2011 and the Area (% of total land area) in Vanuatu in 2012?
Keep it short and to the point. -1.93. What is the difference between the Area (% of total land area) in Uzbekistan in 2011 and the Area (% of total land area) in Vanuatu in 2012?
Give a very brief answer. 47.26. What is the difference between the Area (% of total land area) of High income: nonOECD in 2011 and the Area (% of total land area) of Pacific island small states in 2013?
Provide a succinct answer. 11.42. What is the difference between the Area (% of total land area) in High income: nonOECD in 2011 and the Area (% of total land area) in Uzbekistan in 2013?
Keep it short and to the point. -38.1. What is the difference between the Area (% of total land area) of High income: nonOECD in 2011 and the Area (% of total land area) of Vanuatu in 2013?
Make the answer very short. 9.48. What is the difference between the Area (% of total land area) of Pacific island small states in 2011 and the Area (% of total land area) of Uzbekistan in 2013?
Offer a terse response. -49.52. What is the difference between the Area (% of total land area) of Pacific island small states in 2011 and the Area (% of total land area) of Vanuatu in 2013?
Offer a terse response. -1.93. What is the difference between the Area (% of total land area) in Uzbekistan in 2011 and the Area (% of total land area) in Vanuatu in 2013?
Provide a short and direct response. 47.26. What is the difference between the Area (% of total land area) of High income: nonOECD in 2012 and the Area (% of total land area) of Pacific island small states in 2013?
Your response must be concise. 11.44. What is the difference between the Area (% of total land area) in High income: nonOECD in 2012 and the Area (% of total land area) in Uzbekistan in 2013?
Your answer should be compact. -38.09. What is the difference between the Area (% of total land area) in High income: nonOECD in 2012 and the Area (% of total land area) in Vanuatu in 2013?
Provide a short and direct response. 9.5. What is the difference between the Area (% of total land area) of Pacific island small states in 2012 and the Area (% of total land area) of Uzbekistan in 2013?
Your answer should be very brief. -49.52. What is the difference between the Area (% of total land area) of Pacific island small states in 2012 and the Area (% of total land area) of Vanuatu in 2013?
Your answer should be compact. -1.93. What is the difference between the Area (% of total land area) in Uzbekistan in 2012 and the Area (% of total land area) in Vanuatu in 2013?
Your answer should be compact. 47.54. What is the average Area (% of total land area) of High income: nonOECD per year?
Your response must be concise. 24.75. What is the average Area (% of total land area) in Pacific island small states per year?
Offer a very short reply. 13.37. What is the average Area (% of total land area) of Uzbekistan per year?
Provide a succinct answer. 62.74. What is the average Area (% of total land area) of Vanuatu per year?
Offer a terse response. 15.32. In the year 2006, what is the difference between the Area (% of total land area) in High income: nonOECD and Area (% of total land area) in Pacific island small states?
Ensure brevity in your answer.  11.28. In the year 2006, what is the difference between the Area (% of total land area) in High income: nonOECD and Area (% of total land area) in Uzbekistan?
Your answer should be very brief. -38.28. In the year 2006, what is the difference between the Area (% of total land area) in High income: nonOECD and Area (% of total land area) in Vanuatu?
Provide a short and direct response. 9.4. In the year 2006, what is the difference between the Area (% of total land area) of Pacific island small states and Area (% of total land area) of Uzbekistan?
Offer a very short reply. -49.56. In the year 2006, what is the difference between the Area (% of total land area) in Pacific island small states and Area (% of total land area) in Vanuatu?
Give a very brief answer. -1.88. In the year 2006, what is the difference between the Area (% of total land area) of Uzbekistan and Area (% of total land area) of Vanuatu?
Keep it short and to the point. 47.68. In the year 2007, what is the difference between the Area (% of total land area) in High income: nonOECD and Area (% of total land area) in Pacific island small states?
Your response must be concise. 11.39. In the year 2007, what is the difference between the Area (% of total land area) in High income: nonOECD and Area (% of total land area) in Uzbekistan?
Your answer should be compact. -38.05. In the year 2007, what is the difference between the Area (% of total land area) of High income: nonOECD and Area (% of total land area) of Vanuatu?
Offer a very short reply. 9.35. In the year 2007, what is the difference between the Area (% of total land area) of Pacific island small states and Area (% of total land area) of Uzbekistan?
Ensure brevity in your answer.  -49.44. In the year 2007, what is the difference between the Area (% of total land area) in Pacific island small states and Area (% of total land area) in Vanuatu?
Ensure brevity in your answer.  -2.04. In the year 2007, what is the difference between the Area (% of total land area) in Uzbekistan and Area (% of total land area) in Vanuatu?
Provide a short and direct response. 47.4. In the year 2008, what is the difference between the Area (% of total land area) of High income: nonOECD and Area (% of total land area) of Pacific island small states?
Offer a terse response. 11.38. In the year 2008, what is the difference between the Area (% of total land area) in High income: nonOECD and Area (% of total land area) in Uzbekistan?
Keep it short and to the point. -37.92. In the year 2008, what is the difference between the Area (% of total land area) in High income: nonOECD and Area (% of total land area) in Vanuatu?
Keep it short and to the point. 9.37. In the year 2008, what is the difference between the Area (% of total land area) of Pacific island small states and Area (% of total land area) of Uzbekistan?
Provide a succinct answer. -49.3. In the year 2008, what is the difference between the Area (% of total land area) of Pacific island small states and Area (% of total land area) of Vanuatu?
Ensure brevity in your answer.  -2.01. In the year 2008, what is the difference between the Area (% of total land area) in Uzbekistan and Area (% of total land area) in Vanuatu?
Give a very brief answer. 47.28. In the year 2009, what is the difference between the Area (% of total land area) in High income: nonOECD and Area (% of total land area) in Pacific island small states?
Your answer should be compact. 11.32. In the year 2009, what is the difference between the Area (% of total land area) in High income: nonOECD and Area (% of total land area) in Uzbekistan?
Make the answer very short. -37.9. In the year 2009, what is the difference between the Area (% of total land area) of High income: nonOECD and Area (% of total land area) of Vanuatu?
Offer a terse response. 9.33. In the year 2009, what is the difference between the Area (% of total land area) in Pacific island small states and Area (% of total land area) in Uzbekistan?
Make the answer very short. -49.22. In the year 2009, what is the difference between the Area (% of total land area) in Pacific island small states and Area (% of total land area) in Vanuatu?
Keep it short and to the point. -1.98. In the year 2009, what is the difference between the Area (% of total land area) of Uzbekistan and Area (% of total land area) of Vanuatu?
Your answer should be compact. 47.24. In the year 2010, what is the difference between the Area (% of total land area) in High income: nonOECD and Area (% of total land area) in Pacific island small states?
Ensure brevity in your answer.  11.35. In the year 2010, what is the difference between the Area (% of total land area) of High income: nonOECD and Area (% of total land area) of Uzbekistan?
Ensure brevity in your answer.  -37.94. In the year 2010, what is the difference between the Area (% of total land area) in High income: nonOECD and Area (% of total land area) in Vanuatu?
Provide a succinct answer. 9.42. In the year 2010, what is the difference between the Area (% of total land area) of Pacific island small states and Area (% of total land area) of Uzbekistan?
Offer a terse response. -49.28. In the year 2010, what is the difference between the Area (% of total land area) of Pacific island small states and Area (% of total land area) of Vanuatu?
Keep it short and to the point. -1.93. In the year 2010, what is the difference between the Area (% of total land area) in Uzbekistan and Area (% of total land area) in Vanuatu?
Ensure brevity in your answer.  47.35. In the year 2011, what is the difference between the Area (% of total land area) of High income: nonOECD and Area (% of total land area) of Pacific island small states?
Your answer should be very brief. 11.41. In the year 2011, what is the difference between the Area (% of total land area) of High income: nonOECD and Area (% of total land area) of Uzbekistan?
Offer a very short reply. -37.77. In the year 2011, what is the difference between the Area (% of total land area) of High income: nonOECD and Area (% of total land area) of Vanuatu?
Your response must be concise. 9.48. In the year 2011, what is the difference between the Area (% of total land area) of Pacific island small states and Area (% of total land area) of Uzbekistan?
Make the answer very short. -49.19. In the year 2011, what is the difference between the Area (% of total land area) of Pacific island small states and Area (% of total land area) of Vanuatu?
Your answer should be very brief. -1.93. In the year 2011, what is the difference between the Area (% of total land area) in Uzbekistan and Area (% of total land area) in Vanuatu?
Your answer should be very brief. 47.26. In the year 2012, what is the difference between the Area (% of total land area) in High income: nonOECD and Area (% of total land area) in Pacific island small states?
Your answer should be compact. 11.43. In the year 2012, what is the difference between the Area (% of total land area) in High income: nonOECD and Area (% of total land area) in Uzbekistan?
Your response must be concise. -38.04. In the year 2012, what is the difference between the Area (% of total land area) in High income: nonOECD and Area (% of total land area) in Vanuatu?
Your answer should be compact. 9.5. In the year 2012, what is the difference between the Area (% of total land area) of Pacific island small states and Area (% of total land area) of Uzbekistan?
Your answer should be very brief. -49.47. In the year 2012, what is the difference between the Area (% of total land area) in Pacific island small states and Area (% of total land area) in Vanuatu?
Provide a short and direct response. -1.93. In the year 2012, what is the difference between the Area (% of total land area) of Uzbekistan and Area (% of total land area) of Vanuatu?
Make the answer very short. 47.54. In the year 2013, what is the difference between the Area (% of total land area) in High income: nonOECD and Area (% of total land area) in Pacific island small states?
Your response must be concise. 11.55. In the year 2013, what is the difference between the Area (% of total land area) of High income: nonOECD and Area (% of total land area) of Uzbekistan?
Provide a short and direct response. -37.98. In the year 2013, what is the difference between the Area (% of total land area) in High income: nonOECD and Area (% of total land area) in Vanuatu?
Offer a very short reply. 9.61. In the year 2013, what is the difference between the Area (% of total land area) in Pacific island small states and Area (% of total land area) in Uzbekistan?
Ensure brevity in your answer.  -49.52. In the year 2013, what is the difference between the Area (% of total land area) of Pacific island small states and Area (% of total land area) of Vanuatu?
Provide a short and direct response. -1.94. In the year 2013, what is the difference between the Area (% of total land area) in Uzbekistan and Area (% of total land area) in Vanuatu?
Make the answer very short. 47.59. What is the ratio of the Area (% of total land area) of Uzbekistan in 2006 to that in 2007?
Your response must be concise. 1. What is the ratio of the Area (% of total land area) of Vanuatu in 2006 to that in 2007?
Make the answer very short. 0.99. What is the ratio of the Area (% of total land area) in High income: nonOECD in 2006 to that in 2008?
Keep it short and to the point. 0.99. What is the ratio of the Area (% of total land area) of Pacific island small states in 2006 to that in 2008?
Offer a very short reply. 1. What is the ratio of the Area (% of total land area) of Uzbekistan in 2006 to that in 2008?
Ensure brevity in your answer.  1. What is the ratio of the Area (% of total land area) in Vanuatu in 2006 to that in 2008?
Ensure brevity in your answer.  0.99. What is the ratio of the Area (% of total land area) in High income: nonOECD in 2006 to that in 2009?
Keep it short and to the point. 1. What is the ratio of the Area (% of total land area) in Uzbekistan in 2006 to that in 2009?
Your answer should be compact. 1. What is the ratio of the Area (% of total land area) in Vanuatu in 2006 to that in 2009?
Give a very brief answer. 0.99. What is the ratio of the Area (% of total land area) in Vanuatu in 2006 to that in 2010?
Keep it short and to the point. 0.99. What is the ratio of the Area (% of total land area) of High income: nonOECD in 2006 to that in 2011?
Your answer should be very brief. 0.99. What is the ratio of the Area (% of total land area) in Pacific island small states in 2006 to that in 2011?
Offer a terse response. 0.99. What is the ratio of the Area (% of total land area) of Vanuatu in 2006 to that in 2011?
Provide a short and direct response. 0.99. What is the ratio of the Area (% of total land area) of High income: nonOECD in 2006 to that in 2012?
Make the answer very short. 0.99. What is the ratio of the Area (% of total land area) in Pacific island small states in 2006 to that in 2012?
Offer a terse response. 0.99. What is the ratio of the Area (% of total land area) in Vanuatu in 2006 to that in 2012?
Provide a succinct answer. 0.99. What is the ratio of the Area (% of total land area) of High income: nonOECD in 2006 to that in 2013?
Provide a succinct answer. 0.99. What is the ratio of the Area (% of total land area) in Vanuatu in 2006 to that in 2013?
Your answer should be compact. 0.99. What is the ratio of the Area (% of total land area) of High income: nonOECD in 2007 to that in 2008?
Your response must be concise. 1. What is the ratio of the Area (% of total land area) of Uzbekistan in 2007 to that in 2008?
Your response must be concise. 1. What is the ratio of the Area (% of total land area) of High income: nonOECD in 2007 to that in 2009?
Provide a succinct answer. 1. What is the ratio of the Area (% of total land area) of Uzbekistan in 2007 to that in 2009?
Provide a short and direct response. 1. What is the ratio of the Area (% of total land area) of Pacific island small states in 2007 to that in 2010?
Your response must be concise. 0.99. What is the ratio of the Area (% of total land area) of Uzbekistan in 2007 to that in 2010?
Offer a very short reply. 1. What is the ratio of the Area (% of total land area) of Vanuatu in 2007 to that in 2010?
Give a very brief answer. 1. What is the ratio of the Area (% of total land area) in Pacific island small states in 2007 to that in 2011?
Your answer should be compact. 0.99. What is the ratio of the Area (% of total land area) in High income: nonOECD in 2007 to that in 2012?
Offer a terse response. 0.99. What is the ratio of the Area (% of total land area) of Pacific island small states in 2007 to that in 2012?
Offer a terse response. 0.99. What is the ratio of the Area (% of total land area) of Pacific island small states in 2007 to that in 2013?
Provide a succinct answer. 0.99. What is the ratio of the Area (% of total land area) of Pacific island small states in 2008 to that in 2009?
Your answer should be compact. 1. What is the ratio of the Area (% of total land area) of Vanuatu in 2008 to that in 2009?
Offer a very short reply. 1. What is the ratio of the Area (% of total land area) of Uzbekistan in 2008 to that in 2010?
Keep it short and to the point. 1. What is the ratio of the Area (% of total land area) in Pacific island small states in 2008 to that in 2012?
Give a very brief answer. 0.99. What is the ratio of the Area (% of total land area) of High income: nonOECD in 2008 to that in 2013?
Your answer should be very brief. 0.99. What is the ratio of the Area (% of total land area) of High income: nonOECD in 2009 to that in 2010?
Ensure brevity in your answer.  1. What is the ratio of the Area (% of total land area) of Pacific island small states in 2009 to that in 2010?
Give a very brief answer. 1. What is the ratio of the Area (% of total land area) of Uzbekistan in 2009 to that in 2011?
Ensure brevity in your answer.  1. What is the ratio of the Area (% of total land area) in Vanuatu in 2009 to that in 2011?
Ensure brevity in your answer.  1. What is the ratio of the Area (% of total land area) of High income: nonOECD in 2009 to that in 2012?
Offer a terse response. 0.99. What is the ratio of the Area (% of total land area) in Vanuatu in 2009 to that in 2012?
Your answer should be very brief. 1. What is the ratio of the Area (% of total land area) of Vanuatu in 2009 to that in 2013?
Your answer should be very brief. 1. What is the ratio of the Area (% of total land area) of High income: nonOECD in 2010 to that in 2011?
Provide a short and direct response. 1. What is the ratio of the Area (% of total land area) of Vanuatu in 2010 to that in 2012?
Your answer should be very brief. 1. What is the ratio of the Area (% of total land area) in Uzbekistan in 2010 to that in 2013?
Your response must be concise. 1. What is the ratio of the Area (% of total land area) in Vanuatu in 2010 to that in 2013?
Give a very brief answer. 1. What is the ratio of the Area (% of total land area) in Uzbekistan in 2011 to that in 2012?
Ensure brevity in your answer.  1. What is the ratio of the Area (% of total land area) in Vanuatu in 2011 to that in 2012?
Provide a short and direct response. 1. What is the ratio of the Area (% of total land area) of High income: nonOECD in 2011 to that in 2013?
Offer a terse response. 0.99. What is the ratio of the Area (% of total land area) in Pacific island small states in 2011 to that in 2013?
Give a very brief answer. 1. What is the ratio of the Area (% of total land area) of Pacific island small states in 2012 to that in 2013?
Ensure brevity in your answer.  1. What is the difference between the highest and the second highest Area (% of total land area) in High income: nonOECD?
Make the answer very short. 0.11. What is the difference between the highest and the second highest Area (% of total land area) of Pacific island small states?
Keep it short and to the point. 0. What is the difference between the highest and the second highest Area (% of total land area) of Uzbekistan?
Your answer should be very brief. 0.05. What is the difference between the highest and the second highest Area (% of total land area) in Vanuatu?
Offer a terse response. 0. What is the difference between the highest and the lowest Area (% of total land area) in High income: nonOECD?
Your answer should be very brief. 0.37. What is the difference between the highest and the lowest Area (% of total land area) of Pacific island small states?
Ensure brevity in your answer.  0.12. What is the difference between the highest and the lowest Area (% of total land area) in Uzbekistan?
Your answer should be compact. 0.35. What is the difference between the highest and the lowest Area (% of total land area) in Vanuatu?
Your response must be concise. 0.16. 